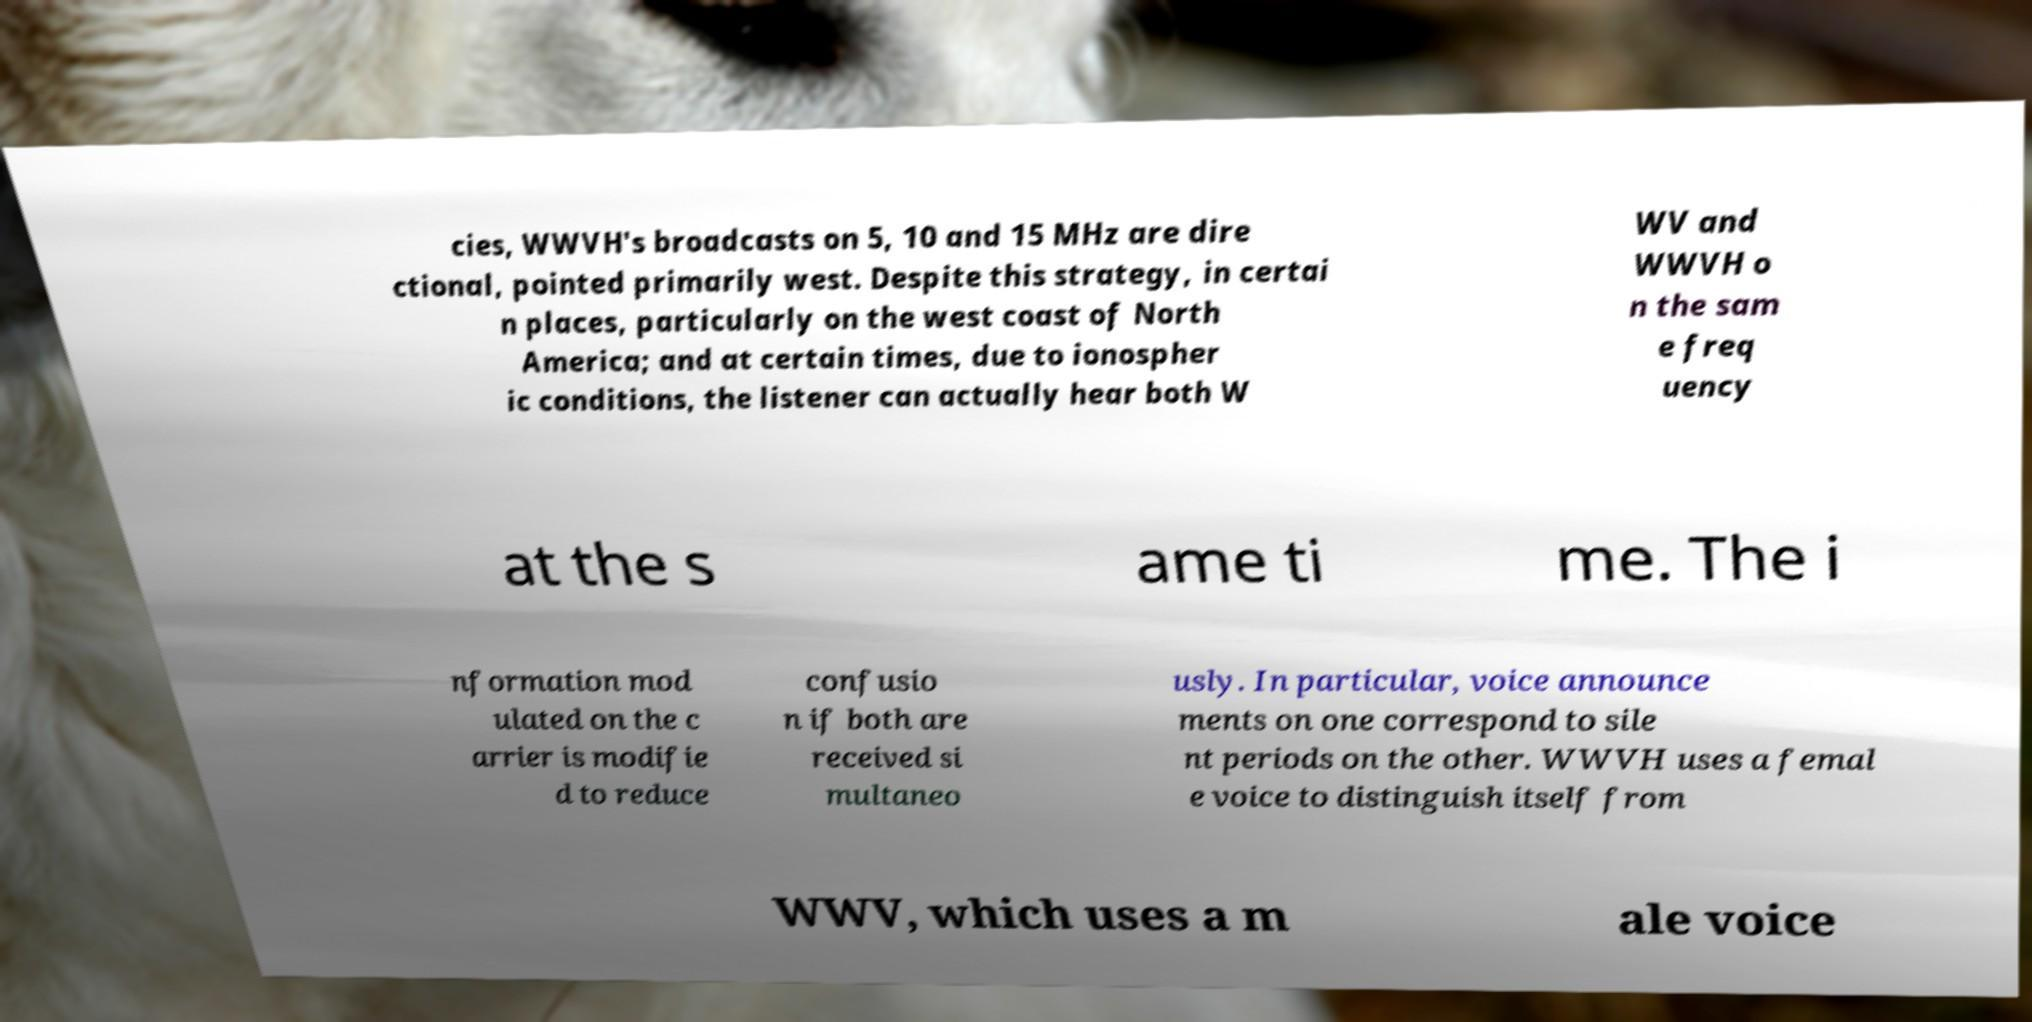Can you read and provide the text displayed in the image?This photo seems to have some interesting text. Can you extract and type it out for me? cies, WWVH's broadcasts on 5, 10 and 15 MHz are dire ctional, pointed primarily west. Despite this strategy, in certai n places, particularly on the west coast of North America; and at certain times, due to ionospher ic conditions, the listener can actually hear both W WV and WWVH o n the sam e freq uency at the s ame ti me. The i nformation mod ulated on the c arrier is modifie d to reduce confusio n if both are received si multaneo usly. In particular, voice announce ments on one correspond to sile nt periods on the other. WWVH uses a femal e voice to distinguish itself from WWV, which uses a m ale voice 